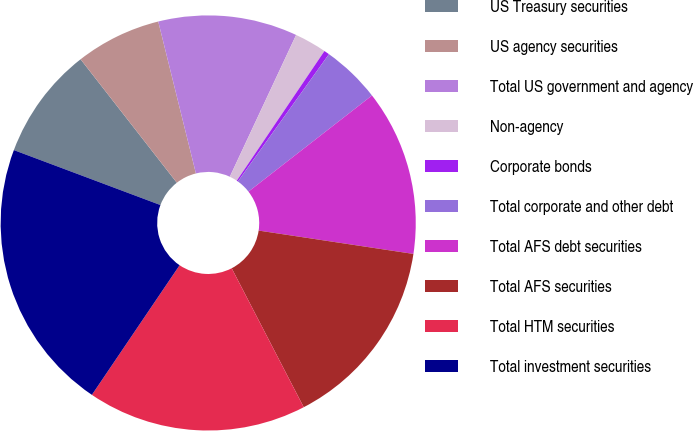<chart> <loc_0><loc_0><loc_500><loc_500><pie_chart><fcel>US Treasury securities<fcel>US agency securities<fcel>Total US government and agency<fcel>Non-agency<fcel>Corporate bonds<fcel>Total corporate and other debt<fcel>Total AFS debt securities<fcel>Total AFS securities<fcel>Total HTM securities<fcel>Total investment securities<nl><fcel>8.75%<fcel>6.67%<fcel>10.83%<fcel>2.5%<fcel>0.42%<fcel>4.59%<fcel>12.91%<fcel>15.0%<fcel>17.08%<fcel>21.24%<nl></chart> 